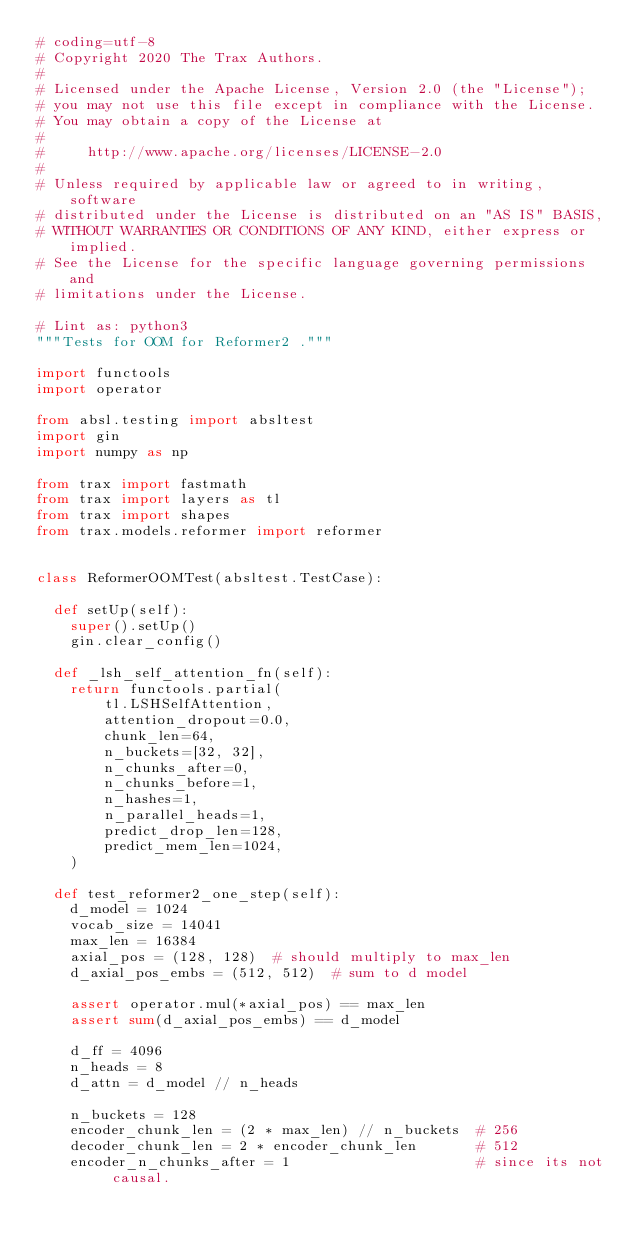Convert code to text. <code><loc_0><loc_0><loc_500><loc_500><_Python_># coding=utf-8
# Copyright 2020 The Trax Authors.
#
# Licensed under the Apache License, Version 2.0 (the "License");
# you may not use this file except in compliance with the License.
# You may obtain a copy of the License at
#
#     http://www.apache.org/licenses/LICENSE-2.0
#
# Unless required by applicable law or agreed to in writing, software
# distributed under the License is distributed on an "AS IS" BASIS,
# WITHOUT WARRANTIES OR CONDITIONS OF ANY KIND, either express or implied.
# See the License for the specific language governing permissions and
# limitations under the License.

# Lint as: python3
"""Tests for OOM for Reformer2 ."""

import functools
import operator

from absl.testing import absltest
import gin
import numpy as np

from trax import fastmath
from trax import layers as tl
from trax import shapes
from trax.models.reformer import reformer


class ReformerOOMTest(absltest.TestCase):

  def setUp(self):
    super().setUp()
    gin.clear_config()

  def _lsh_self_attention_fn(self):
    return functools.partial(
        tl.LSHSelfAttention,
        attention_dropout=0.0,
        chunk_len=64,
        n_buckets=[32, 32],
        n_chunks_after=0,
        n_chunks_before=1,
        n_hashes=1,
        n_parallel_heads=1,
        predict_drop_len=128,
        predict_mem_len=1024,
    )

  def test_reformer2_one_step(self):
    d_model = 1024
    vocab_size = 14041
    max_len = 16384
    axial_pos = (128, 128)  # should multiply to max_len
    d_axial_pos_embs = (512, 512)  # sum to d model

    assert operator.mul(*axial_pos) == max_len
    assert sum(d_axial_pos_embs) == d_model

    d_ff = 4096
    n_heads = 8
    d_attn = d_model // n_heads

    n_buckets = 128
    encoder_chunk_len = (2 * max_len) // n_buckets  # 256
    decoder_chunk_len = 2 * encoder_chunk_len       # 512
    encoder_n_chunks_after = 1                      # since its not causal.
</code> 